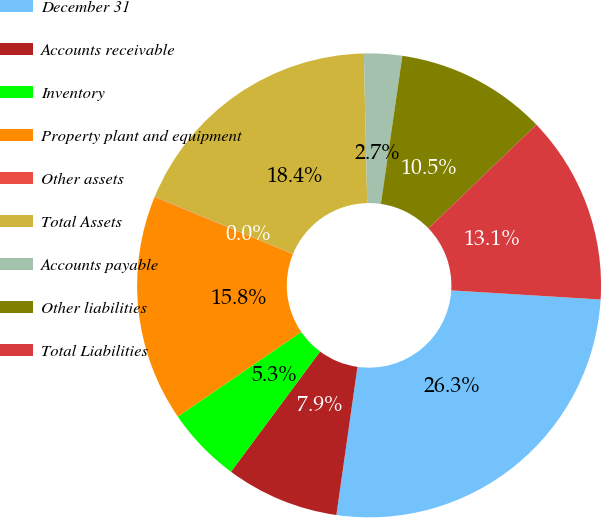Convert chart to OTSL. <chart><loc_0><loc_0><loc_500><loc_500><pie_chart><fcel>December 31<fcel>Accounts receivable<fcel>Inventory<fcel>Property plant and equipment<fcel>Other assets<fcel>Total Assets<fcel>Accounts payable<fcel>Other liabilities<fcel>Total Liabilities<nl><fcel>26.28%<fcel>7.9%<fcel>5.28%<fcel>15.78%<fcel>0.03%<fcel>18.4%<fcel>2.65%<fcel>10.53%<fcel>13.15%<nl></chart> 